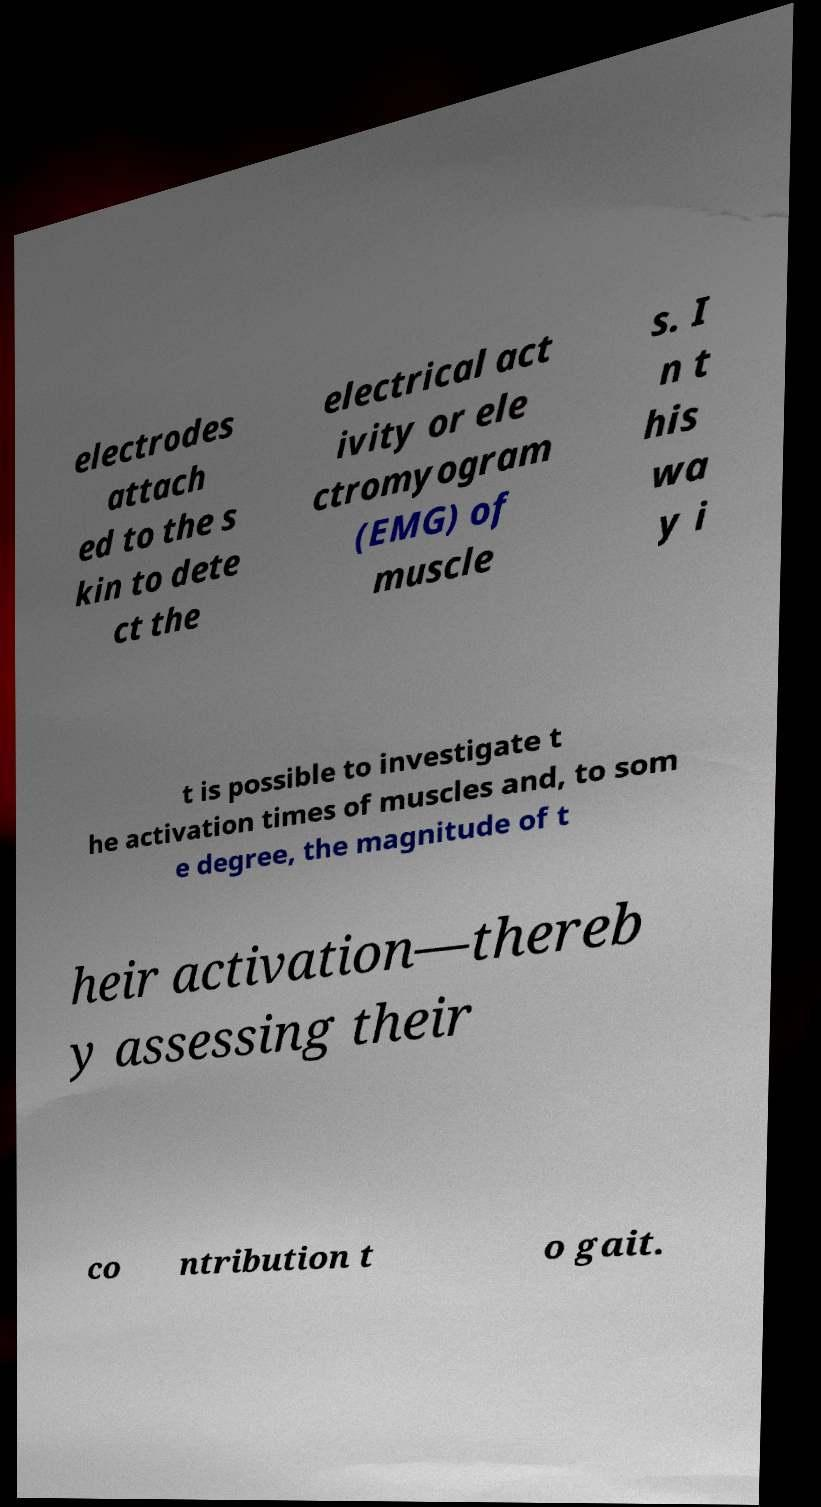Please read and relay the text visible in this image. What does it say? electrodes attach ed to the s kin to dete ct the electrical act ivity or ele ctromyogram (EMG) of muscle s. I n t his wa y i t is possible to investigate t he activation times of muscles and, to som e degree, the magnitude of t heir activation—thereb y assessing their co ntribution t o gait. 